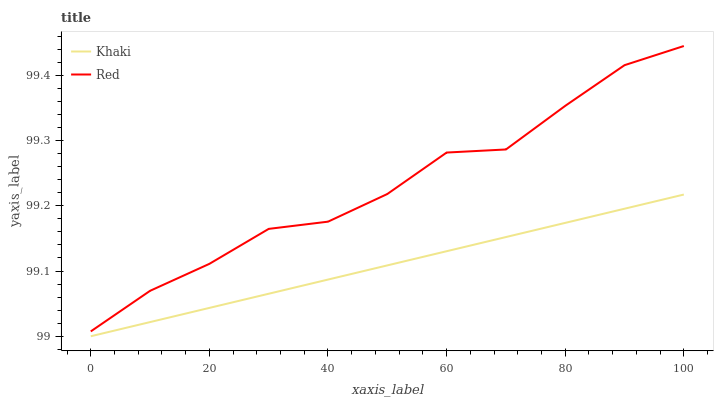Does Khaki have the minimum area under the curve?
Answer yes or no. Yes. Does Red have the maximum area under the curve?
Answer yes or no. Yes. Does Red have the minimum area under the curve?
Answer yes or no. No. Is Khaki the smoothest?
Answer yes or no. Yes. Is Red the roughest?
Answer yes or no. Yes. Is Red the smoothest?
Answer yes or no. No. Does Khaki have the lowest value?
Answer yes or no. Yes. Does Red have the lowest value?
Answer yes or no. No. Does Red have the highest value?
Answer yes or no. Yes. Is Khaki less than Red?
Answer yes or no. Yes. Is Red greater than Khaki?
Answer yes or no. Yes. Does Khaki intersect Red?
Answer yes or no. No. 